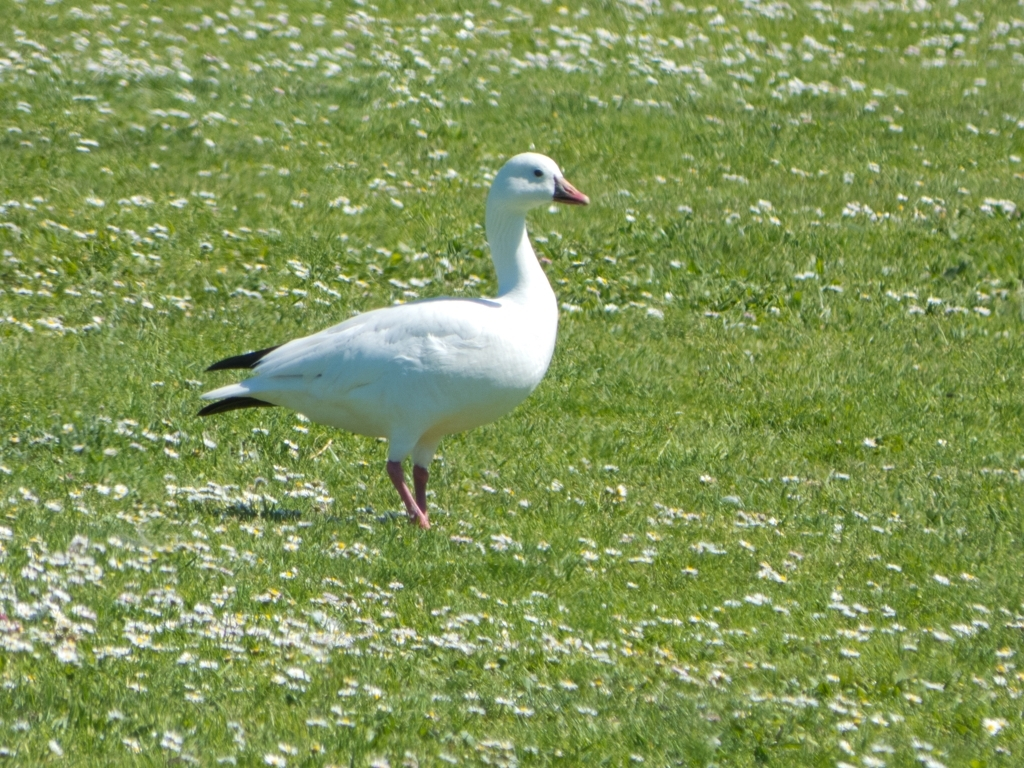Are there any quality issues with this image? The image appears to be slightly overexposed with a slight lack of sharpness, particularly noticeable in the textures of the grass and the feathers of the bird. Furthermore, there could have been a better composition to enhance the visual appeal of the subject, which is a bird, by perhaps adjusting the framing to follow the rule of thirds. 